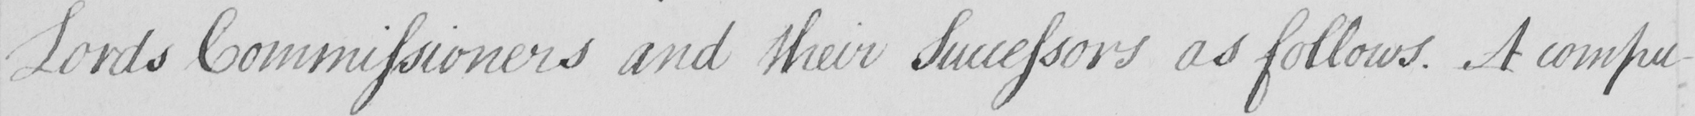What does this handwritten line say? Lords Commissioners and their Successors as follows . A compu- 